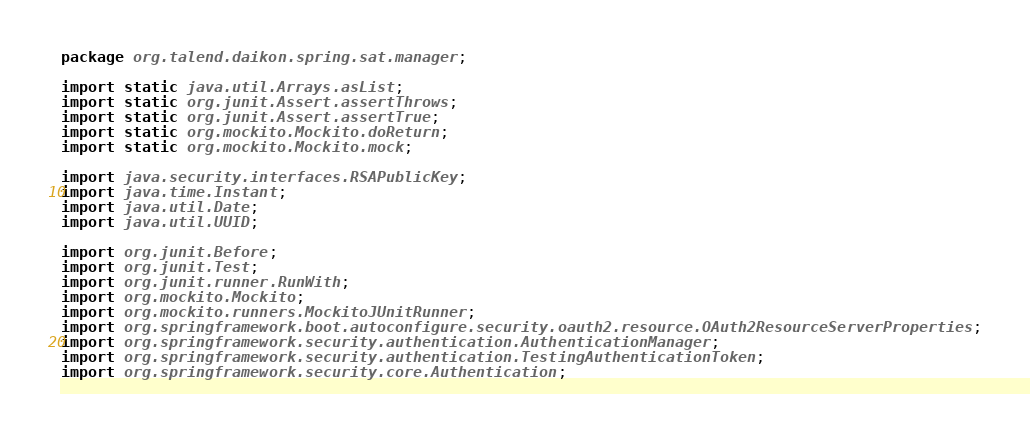Convert code to text. <code><loc_0><loc_0><loc_500><loc_500><_Java_>package org.talend.daikon.spring.sat.manager;

import static java.util.Arrays.asList;
import static org.junit.Assert.assertThrows;
import static org.junit.Assert.assertTrue;
import static org.mockito.Mockito.doReturn;
import static org.mockito.Mockito.mock;

import java.security.interfaces.RSAPublicKey;
import java.time.Instant;
import java.util.Date;
import java.util.UUID;

import org.junit.Before;
import org.junit.Test;
import org.junit.runner.RunWith;
import org.mockito.Mockito;
import org.mockito.runners.MockitoJUnitRunner;
import org.springframework.boot.autoconfigure.security.oauth2.resource.OAuth2ResourceServerProperties;
import org.springframework.security.authentication.AuthenticationManager;
import org.springframework.security.authentication.TestingAuthenticationToken;
import org.springframework.security.core.Authentication;</code> 